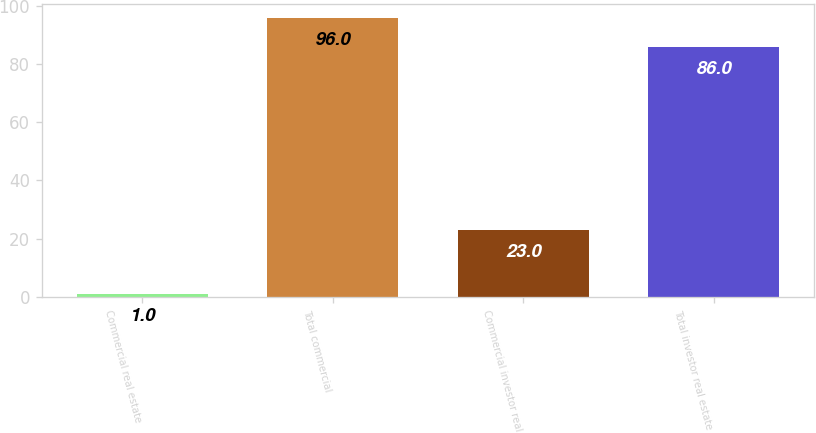Convert chart. <chart><loc_0><loc_0><loc_500><loc_500><bar_chart><fcel>Commercial real estate<fcel>Total commercial<fcel>Commercial investor real<fcel>Total investor real estate<nl><fcel>1<fcel>96<fcel>23<fcel>86<nl></chart> 